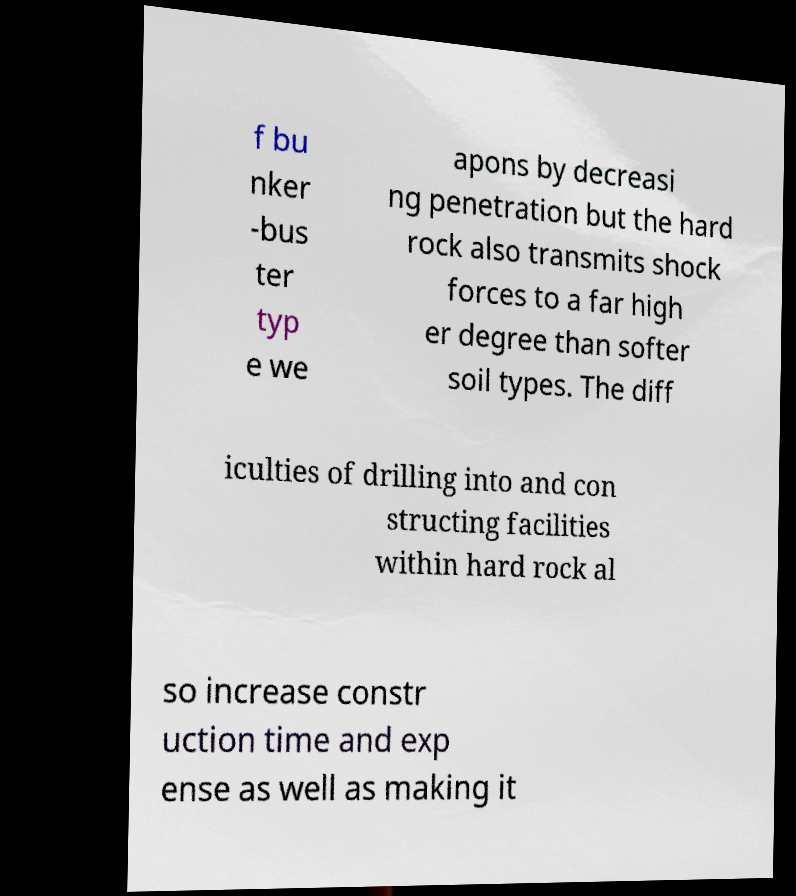Please read and relay the text visible in this image. What does it say? f bu nker -bus ter typ e we apons by decreasi ng penetration but the hard rock also transmits shock forces to a far high er degree than softer soil types. The diff iculties of drilling into and con structing facilities within hard rock al so increase constr uction time and exp ense as well as making it 